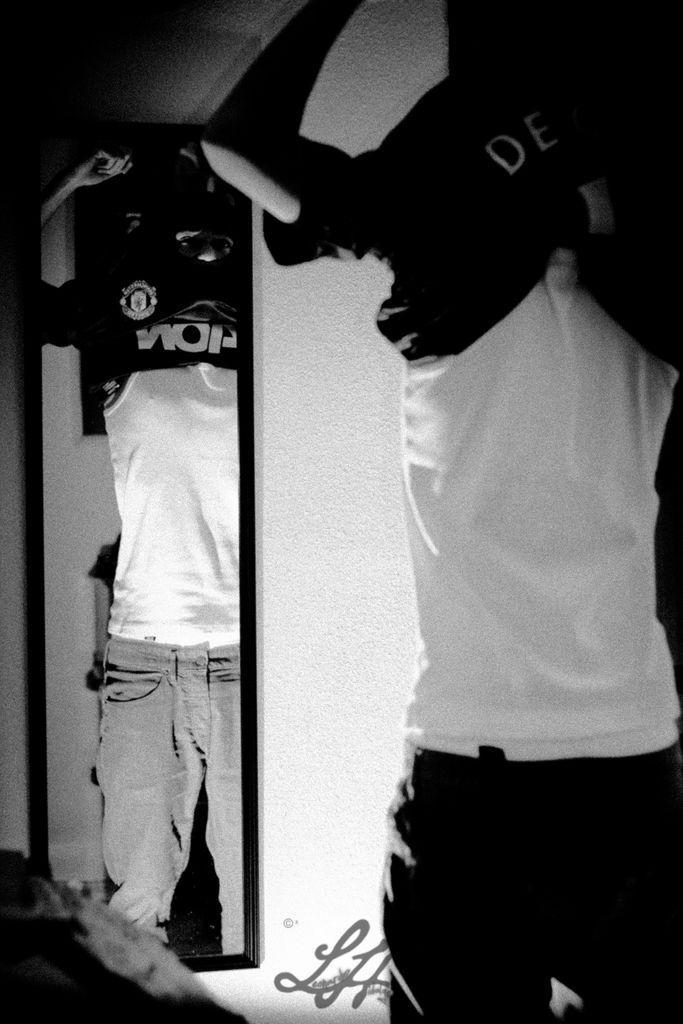Can you describe this image briefly? This is a black and white picture. In this picture we can see a man and looks like he is wearing a t-shirt. In the background we can see the wall. We can see the reflection in a mirror. At the bottom portion of the picture there is something written. 